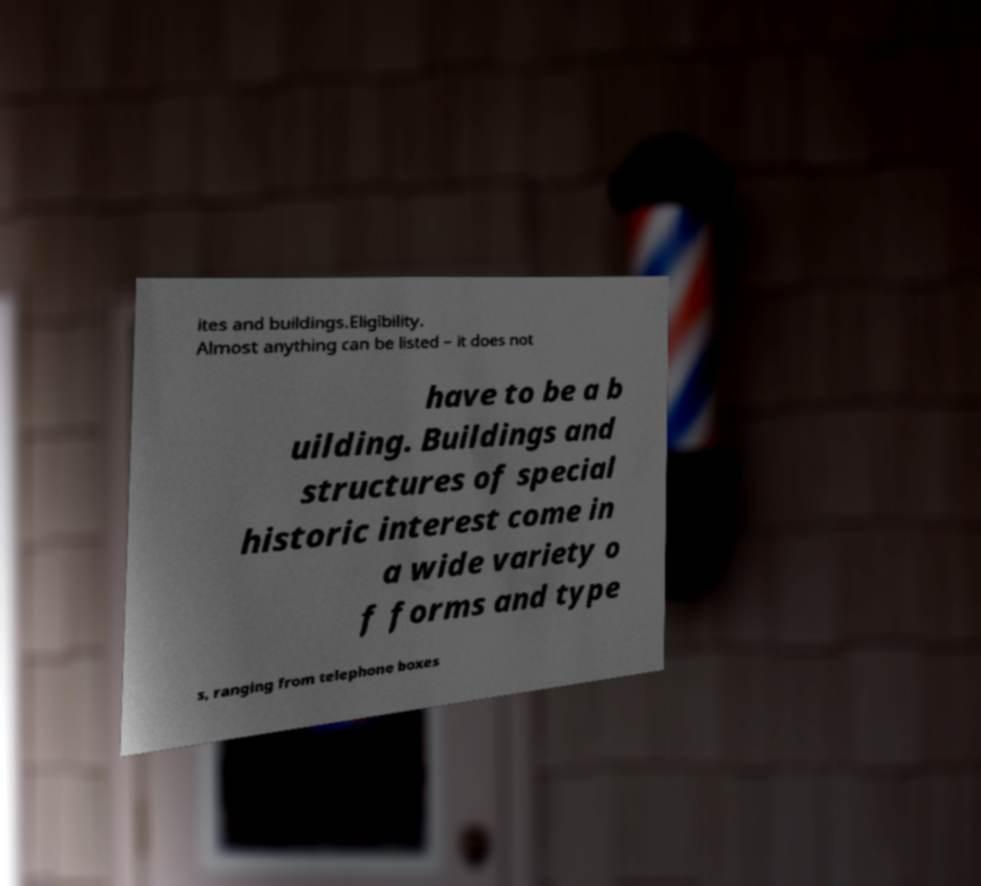I need the written content from this picture converted into text. Can you do that? ites and buildings.Eligibility. Almost anything can be listed – it does not have to be a b uilding. Buildings and structures of special historic interest come in a wide variety o f forms and type s, ranging from telephone boxes 